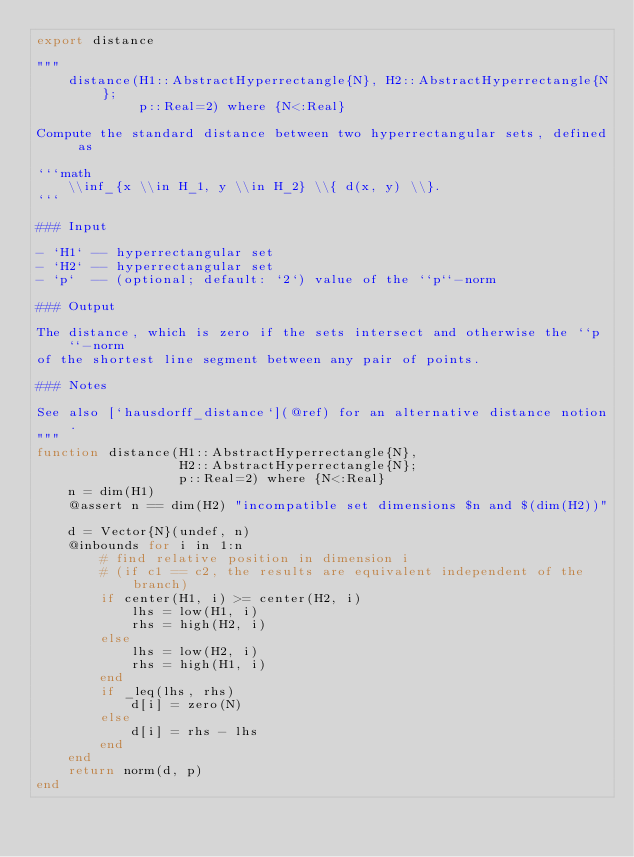Convert code to text. <code><loc_0><loc_0><loc_500><loc_500><_Julia_>export distance

"""
    distance(H1::AbstractHyperrectangle{N}, H2::AbstractHyperrectangle{N};
             p::Real=2) where {N<:Real}

Compute the standard distance between two hyperrectangular sets, defined as

```math
    \\inf_{x \\in H_1, y \\in H_2} \\{ d(x, y) \\}.
```

### Input

- `H1` -- hyperrectangular set
- `H2` -- hyperrectangular set
- `p`  -- (optional; default: `2`) value of the ``p``-norm

### Output

The distance, which is zero if the sets intersect and otherwise the ``p``-norm
of the shortest line segment between any pair of points.

### Notes

See also [`hausdorff_distance`](@ref) for an alternative distance notion.
"""
function distance(H1::AbstractHyperrectangle{N},
                  H2::AbstractHyperrectangle{N};
                  p::Real=2) where {N<:Real}
    n = dim(H1)
    @assert n == dim(H2) "incompatible set dimensions $n and $(dim(H2))"

    d = Vector{N}(undef, n)
    @inbounds for i in 1:n
        # find relative position in dimension i
        # (if c1 == c2, the results are equivalent independent of the branch)
        if center(H1, i) >= center(H2, i)
            lhs = low(H1, i)
            rhs = high(H2, i)
        else
            lhs = low(H2, i)
            rhs = high(H1, i)
        end
        if _leq(lhs, rhs)
            d[i] = zero(N)
        else
            d[i] = rhs - lhs
        end
    end
    return norm(d, p)
end
</code> 